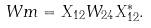<formula> <loc_0><loc_0><loc_500><loc_500>\ W m = X _ { 1 2 } W _ { 2 4 } X _ { 1 2 } ^ { * } .</formula> 